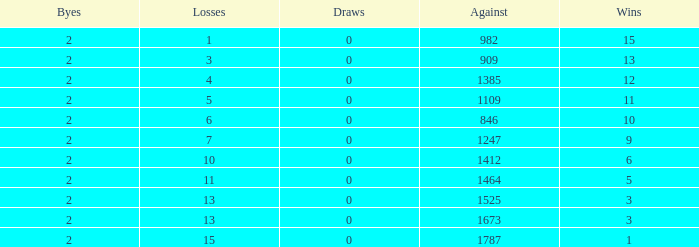What is the highest number listed under against when there were 15 losses and more than 1 win? None. 